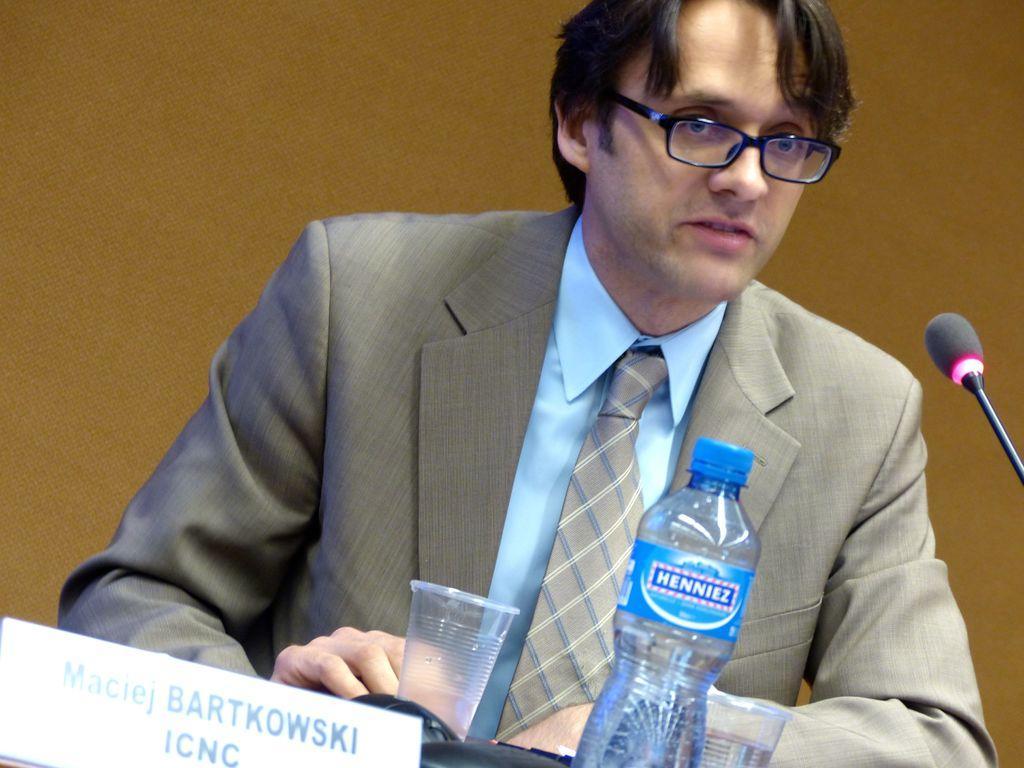Describe this image in one or two sentences. In this image there is a person wearing suit sitting on the table and in front of him there is a microphone,water bottle and glasses. 